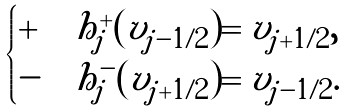Convert formula to latex. <formula><loc_0><loc_0><loc_500><loc_500>\begin{cases} + & h ^ { + } _ { j } ( v _ { j - 1 / 2 } ) = v _ { j + 1 / 2 } , \\ - & h ^ { - } _ { j } ( v _ { j + 1 / 2 } ) = v _ { j - 1 / 2 } . \end{cases}</formula> 